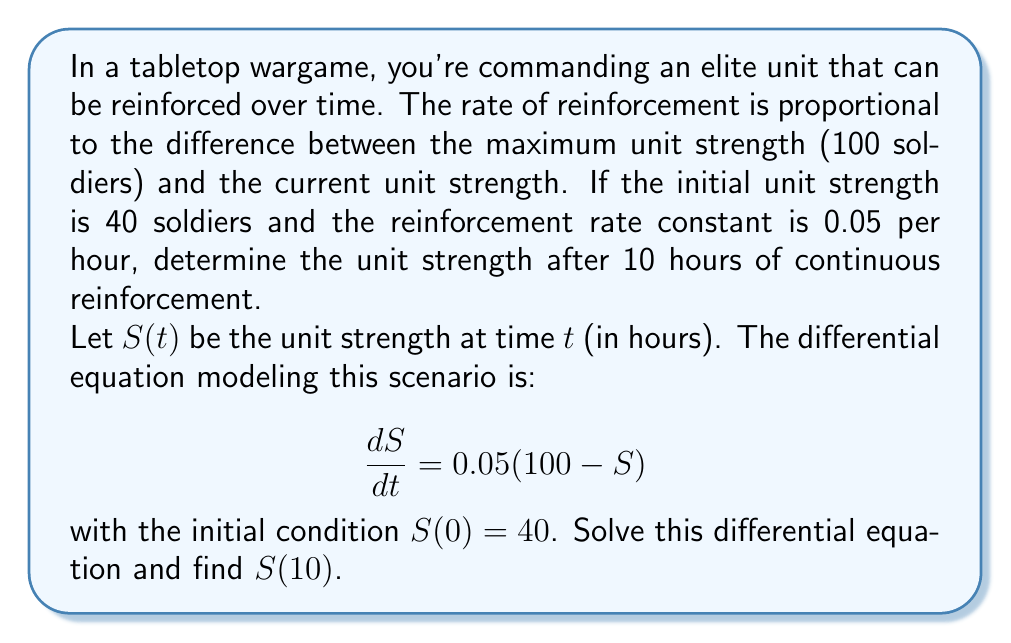Provide a solution to this math problem. Let's solve this step-by-step:

1) The differential equation is in the form $\frac{dS}{dt} + 0.05S = 5$, which is a first-order linear differential equation.

2) The integrating factor is $e^{\int 0.05 dt} = e^{0.05t}$.

3) Multiply both sides of the equation by the integrating factor:
   $$e^{0.05t}\frac{dS}{dt} + 0.05e^{0.05t}S = 5e^{0.05t}$$

4) The left side is now the derivative of $e^{0.05t}S$:
   $$\frac{d}{dt}(e^{0.05t}S) = 5e^{0.05t}$$

5) Integrate both sides:
   $$e^{0.05t}S = 100e^{0.05t} + C$$

6) Solve for $S$:
   $$S = 100 + Ce^{-0.05t}$$

7) Use the initial condition $S(0) = 40$ to find $C$:
   $$40 = 100 + C$$
   $$C = -60$$

8) The general solution is:
   $$S(t) = 100 - 60e^{-0.05t}$$

9) To find $S(10)$, substitute $t = 10$:
   $$S(10) = 100 - 60e^{-0.5} \approx 73.93$$
Answer: $S(10) \approx 73.93$ soldiers 